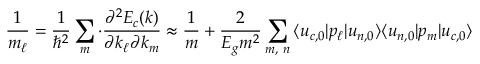<formula> <loc_0><loc_0><loc_500><loc_500>{ \frac { 1 } { { m } _ { \ell } } } = { \frac { 1 } { \hbar { ^ } { 2 } } } \sum _ { m } \cdot { \frac { \partial ^ { 2 } E _ { c } ( { k } ) } { \partial k _ { \ell } \partial k _ { m } } } \approx { \frac { 1 } { m } } + { \frac { 2 } { E _ { g } m ^ { 2 } } } \sum _ { m , \ n } { \langle u _ { c , 0 } | p _ { \ell } | u _ { n , 0 } \rangle } { \langle u _ { n , 0 } | p _ { m } | u _ { c , 0 } \rangle }</formula> 